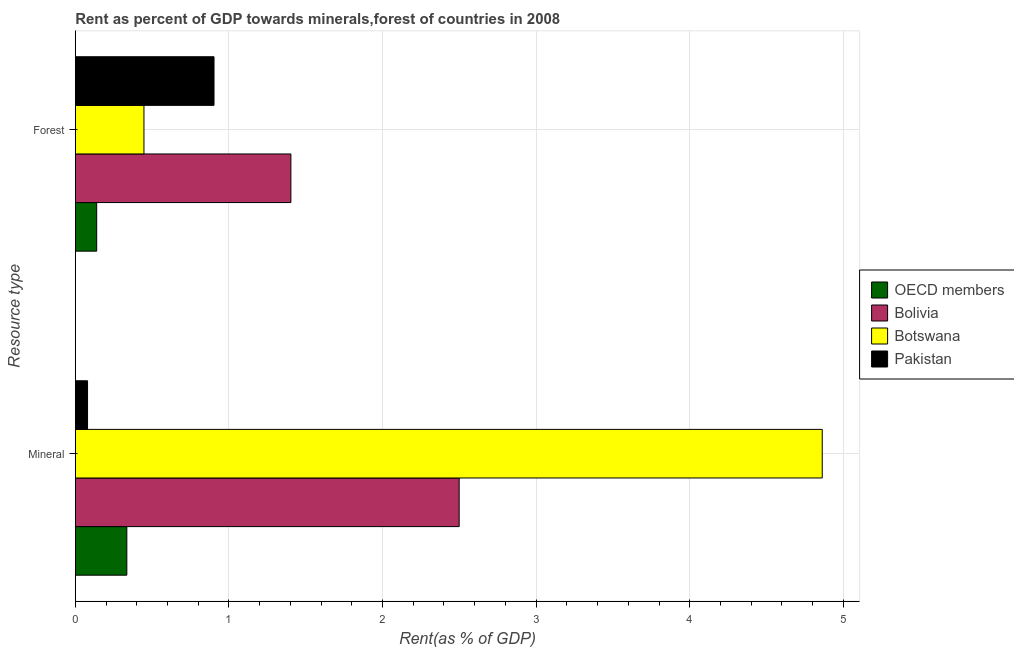Are the number of bars on each tick of the Y-axis equal?
Your response must be concise. Yes. How many bars are there on the 2nd tick from the top?
Provide a succinct answer. 4. What is the label of the 1st group of bars from the top?
Offer a terse response. Forest. What is the mineral rent in Bolivia?
Give a very brief answer. 2.5. Across all countries, what is the maximum mineral rent?
Provide a succinct answer. 4.86. Across all countries, what is the minimum forest rent?
Provide a short and direct response. 0.14. In which country was the mineral rent maximum?
Ensure brevity in your answer.  Botswana. In which country was the forest rent minimum?
Offer a terse response. OECD members. What is the total mineral rent in the graph?
Keep it short and to the point. 7.78. What is the difference between the mineral rent in OECD members and that in Bolivia?
Ensure brevity in your answer.  -2.16. What is the difference between the forest rent in OECD members and the mineral rent in Botswana?
Make the answer very short. -4.72. What is the average mineral rent per country?
Offer a terse response. 1.94. What is the difference between the mineral rent and forest rent in Pakistan?
Ensure brevity in your answer.  -0.82. What is the ratio of the forest rent in Pakistan to that in OECD members?
Provide a short and direct response. 6.48. In how many countries, is the mineral rent greater than the average mineral rent taken over all countries?
Give a very brief answer. 2. What does the 3rd bar from the top in Mineral represents?
Offer a terse response. Bolivia. What does the 1st bar from the bottom in Forest represents?
Your answer should be compact. OECD members. Are all the bars in the graph horizontal?
Provide a succinct answer. Yes. How many countries are there in the graph?
Your answer should be very brief. 4. What is the difference between two consecutive major ticks on the X-axis?
Ensure brevity in your answer.  1. Are the values on the major ticks of X-axis written in scientific E-notation?
Give a very brief answer. No. How are the legend labels stacked?
Your response must be concise. Vertical. What is the title of the graph?
Provide a succinct answer. Rent as percent of GDP towards minerals,forest of countries in 2008. Does "Togo" appear as one of the legend labels in the graph?
Provide a succinct answer. No. What is the label or title of the X-axis?
Give a very brief answer. Rent(as % of GDP). What is the label or title of the Y-axis?
Provide a short and direct response. Resource type. What is the Rent(as % of GDP) in OECD members in Mineral?
Provide a short and direct response. 0.34. What is the Rent(as % of GDP) of Bolivia in Mineral?
Provide a succinct answer. 2.5. What is the Rent(as % of GDP) in Botswana in Mineral?
Your response must be concise. 4.86. What is the Rent(as % of GDP) of Pakistan in Mineral?
Ensure brevity in your answer.  0.08. What is the Rent(as % of GDP) of OECD members in Forest?
Ensure brevity in your answer.  0.14. What is the Rent(as % of GDP) of Bolivia in Forest?
Keep it short and to the point. 1.4. What is the Rent(as % of GDP) in Botswana in Forest?
Offer a terse response. 0.45. What is the Rent(as % of GDP) of Pakistan in Forest?
Provide a short and direct response. 0.9. Across all Resource type, what is the maximum Rent(as % of GDP) in OECD members?
Offer a terse response. 0.34. Across all Resource type, what is the maximum Rent(as % of GDP) in Bolivia?
Give a very brief answer. 2.5. Across all Resource type, what is the maximum Rent(as % of GDP) of Botswana?
Your response must be concise. 4.86. Across all Resource type, what is the maximum Rent(as % of GDP) of Pakistan?
Give a very brief answer. 0.9. Across all Resource type, what is the minimum Rent(as % of GDP) in OECD members?
Your answer should be compact. 0.14. Across all Resource type, what is the minimum Rent(as % of GDP) in Bolivia?
Ensure brevity in your answer.  1.4. Across all Resource type, what is the minimum Rent(as % of GDP) of Botswana?
Offer a very short reply. 0.45. Across all Resource type, what is the minimum Rent(as % of GDP) in Pakistan?
Your answer should be very brief. 0.08. What is the total Rent(as % of GDP) of OECD members in the graph?
Your answer should be very brief. 0.47. What is the total Rent(as % of GDP) of Bolivia in the graph?
Keep it short and to the point. 3.9. What is the total Rent(as % of GDP) of Botswana in the graph?
Offer a very short reply. 5.31. What is the total Rent(as % of GDP) in Pakistan in the graph?
Provide a succinct answer. 0.98. What is the difference between the Rent(as % of GDP) of OECD members in Mineral and that in Forest?
Your response must be concise. 0.2. What is the difference between the Rent(as % of GDP) of Bolivia in Mineral and that in Forest?
Keep it short and to the point. 1.1. What is the difference between the Rent(as % of GDP) in Botswana in Mineral and that in Forest?
Make the answer very short. 4.42. What is the difference between the Rent(as % of GDP) in Pakistan in Mineral and that in Forest?
Provide a short and direct response. -0.82. What is the difference between the Rent(as % of GDP) of OECD members in Mineral and the Rent(as % of GDP) of Bolivia in Forest?
Give a very brief answer. -1.07. What is the difference between the Rent(as % of GDP) of OECD members in Mineral and the Rent(as % of GDP) of Botswana in Forest?
Provide a short and direct response. -0.11. What is the difference between the Rent(as % of GDP) in OECD members in Mineral and the Rent(as % of GDP) in Pakistan in Forest?
Offer a very short reply. -0.57. What is the difference between the Rent(as % of GDP) of Bolivia in Mineral and the Rent(as % of GDP) of Botswana in Forest?
Make the answer very short. 2.05. What is the difference between the Rent(as % of GDP) of Bolivia in Mineral and the Rent(as % of GDP) of Pakistan in Forest?
Make the answer very short. 1.6. What is the difference between the Rent(as % of GDP) of Botswana in Mineral and the Rent(as % of GDP) of Pakistan in Forest?
Offer a terse response. 3.96. What is the average Rent(as % of GDP) in OECD members per Resource type?
Offer a terse response. 0.24. What is the average Rent(as % of GDP) in Bolivia per Resource type?
Make the answer very short. 1.95. What is the average Rent(as % of GDP) of Botswana per Resource type?
Your response must be concise. 2.65. What is the average Rent(as % of GDP) of Pakistan per Resource type?
Offer a very short reply. 0.49. What is the difference between the Rent(as % of GDP) of OECD members and Rent(as % of GDP) of Bolivia in Mineral?
Your response must be concise. -2.16. What is the difference between the Rent(as % of GDP) in OECD members and Rent(as % of GDP) in Botswana in Mineral?
Give a very brief answer. -4.53. What is the difference between the Rent(as % of GDP) in OECD members and Rent(as % of GDP) in Pakistan in Mineral?
Give a very brief answer. 0.26. What is the difference between the Rent(as % of GDP) in Bolivia and Rent(as % of GDP) in Botswana in Mineral?
Your answer should be compact. -2.36. What is the difference between the Rent(as % of GDP) of Bolivia and Rent(as % of GDP) of Pakistan in Mineral?
Offer a terse response. 2.42. What is the difference between the Rent(as % of GDP) in Botswana and Rent(as % of GDP) in Pakistan in Mineral?
Offer a terse response. 4.78. What is the difference between the Rent(as % of GDP) in OECD members and Rent(as % of GDP) in Bolivia in Forest?
Your answer should be compact. -1.26. What is the difference between the Rent(as % of GDP) in OECD members and Rent(as % of GDP) in Botswana in Forest?
Provide a succinct answer. -0.31. What is the difference between the Rent(as % of GDP) of OECD members and Rent(as % of GDP) of Pakistan in Forest?
Make the answer very short. -0.76. What is the difference between the Rent(as % of GDP) of Bolivia and Rent(as % of GDP) of Botswana in Forest?
Your answer should be compact. 0.96. What is the difference between the Rent(as % of GDP) in Bolivia and Rent(as % of GDP) in Pakistan in Forest?
Your answer should be very brief. 0.5. What is the difference between the Rent(as % of GDP) in Botswana and Rent(as % of GDP) in Pakistan in Forest?
Your answer should be compact. -0.46. What is the ratio of the Rent(as % of GDP) in OECD members in Mineral to that in Forest?
Ensure brevity in your answer.  2.41. What is the ratio of the Rent(as % of GDP) in Bolivia in Mineral to that in Forest?
Provide a succinct answer. 1.78. What is the ratio of the Rent(as % of GDP) in Botswana in Mineral to that in Forest?
Keep it short and to the point. 10.88. What is the ratio of the Rent(as % of GDP) of Pakistan in Mineral to that in Forest?
Provide a short and direct response. 0.09. What is the difference between the highest and the second highest Rent(as % of GDP) in OECD members?
Ensure brevity in your answer.  0.2. What is the difference between the highest and the second highest Rent(as % of GDP) in Bolivia?
Your response must be concise. 1.1. What is the difference between the highest and the second highest Rent(as % of GDP) in Botswana?
Your answer should be compact. 4.42. What is the difference between the highest and the second highest Rent(as % of GDP) in Pakistan?
Your response must be concise. 0.82. What is the difference between the highest and the lowest Rent(as % of GDP) of OECD members?
Keep it short and to the point. 0.2. What is the difference between the highest and the lowest Rent(as % of GDP) in Bolivia?
Give a very brief answer. 1.1. What is the difference between the highest and the lowest Rent(as % of GDP) of Botswana?
Provide a succinct answer. 4.42. What is the difference between the highest and the lowest Rent(as % of GDP) of Pakistan?
Ensure brevity in your answer.  0.82. 